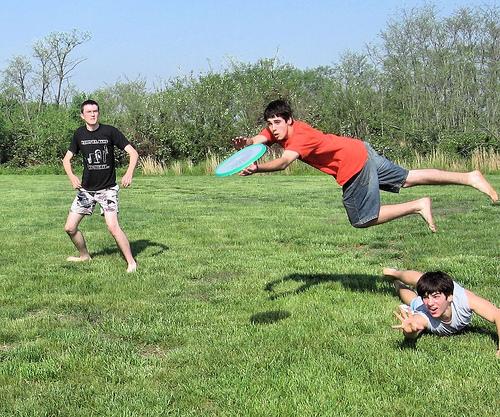Who is most likely to make the catch?
Short answer required. Red shirt. What is everyone trying to catch?
Write a very short answer. Frisbee. How many people are in the photo?
Short answer required. 3. 